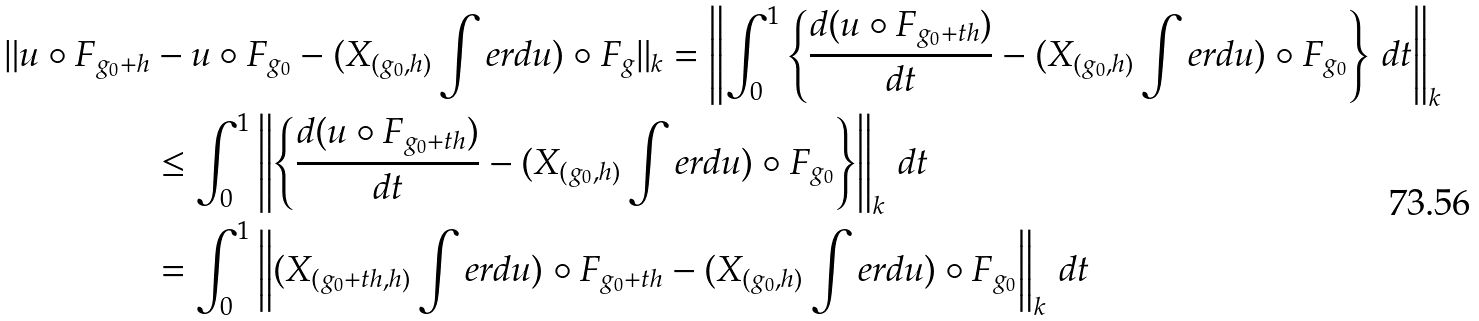<formula> <loc_0><loc_0><loc_500><loc_500>\| u \circ F _ { g _ { 0 } + h } & - u \circ F _ { g _ { 0 } } - ( X _ { ( g _ { 0 } , h ) } \int e r d u ) \circ F _ { g } \| _ { k } = \left \| \int _ { 0 } ^ { 1 } \left \{ \frac { d ( u \circ F _ { g _ { 0 } + t h } ) } { d t } - ( X _ { ( g _ { 0 } , h ) } \int e r d u ) \circ F _ { g _ { 0 } } \right \} \, d t \right \| _ { k } \\ & \leq \int _ { 0 } ^ { 1 } \left \| \left \{ \frac { d ( u \circ F _ { g _ { 0 } + t h } ) } { d t } - ( X _ { ( g _ { 0 } , h ) } \int e r d u ) \circ F _ { g _ { 0 } } \right \} \right \| _ { k } \, d t \\ & = \int _ { 0 } ^ { 1 } \left \| ( X _ { ( g _ { 0 } + t h , h ) } \int e r d u ) \circ F _ { g _ { 0 } + t h } - ( X _ { ( g _ { 0 } , h ) } \int e r d u ) \circ F _ { g _ { 0 } } \right \| _ { k } \, d t</formula> 